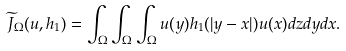Convert formula to latex. <formula><loc_0><loc_0><loc_500><loc_500>\widetilde { J } _ { \Omega } ( u , h _ { 1 } ) = \int _ { \Omega } \int _ { \Omega } \int _ { \Omega } u ( y ) h _ { 1 } ( | y - x | ) u ( x ) d z d y d x .</formula> 